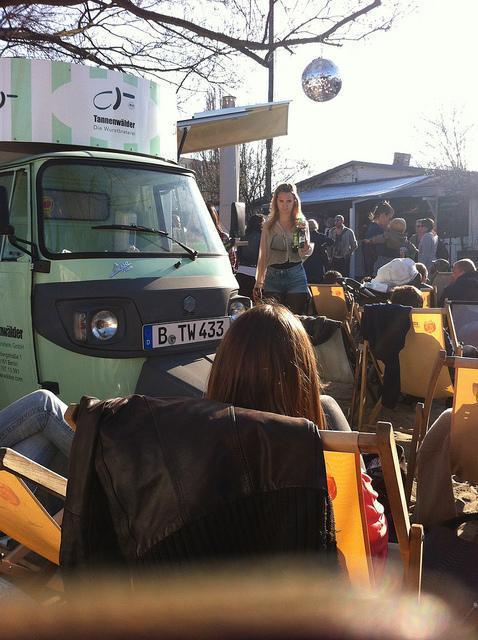How many chairs are visible?
Give a very brief answer. 3. How many people are there?
Give a very brief answer. 3. 